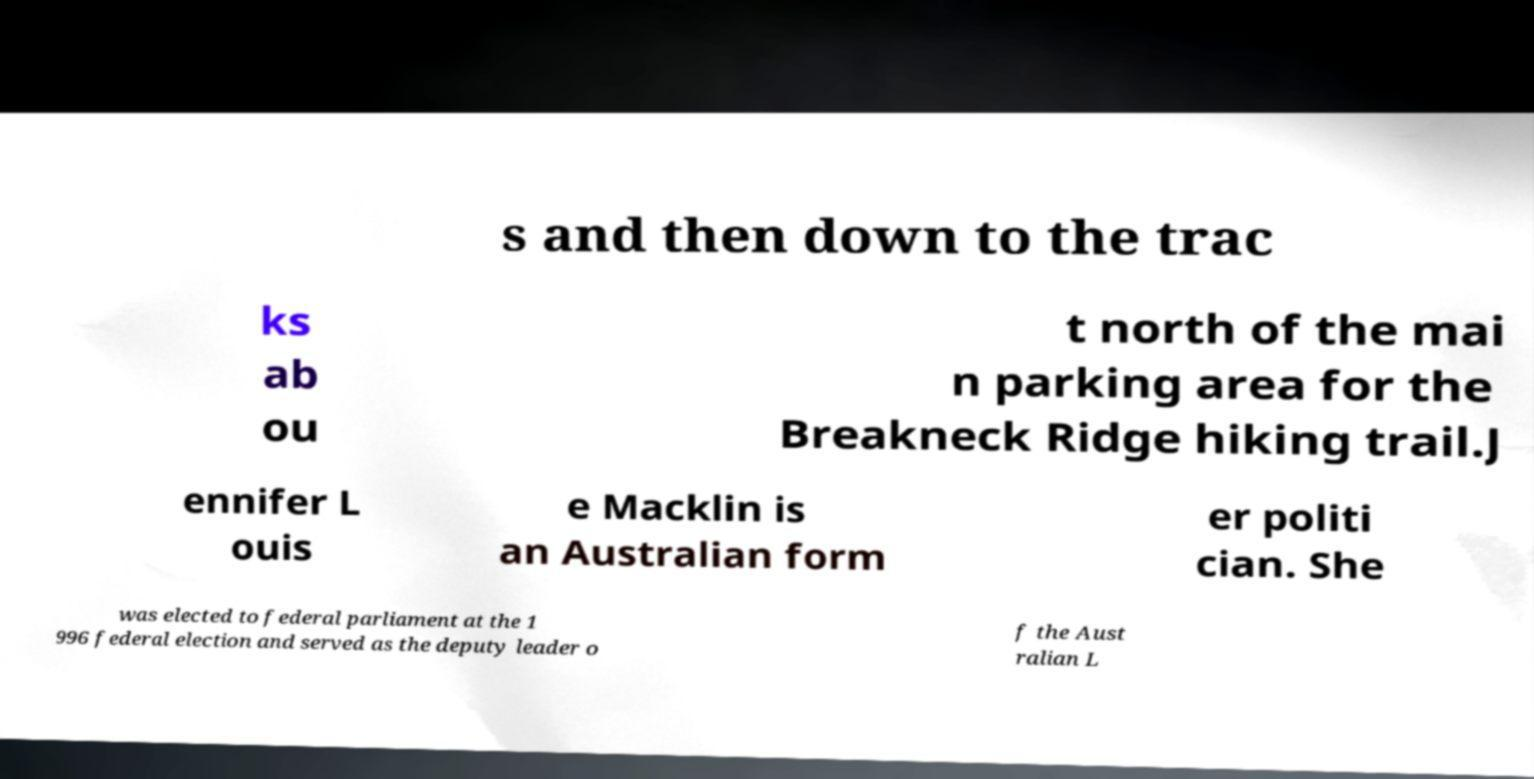Please read and relay the text visible in this image. What does it say? s and then down to the trac ks ab ou t north of the mai n parking area for the Breakneck Ridge hiking trail.J ennifer L ouis e Macklin is an Australian form er politi cian. She was elected to federal parliament at the 1 996 federal election and served as the deputy leader o f the Aust ralian L 